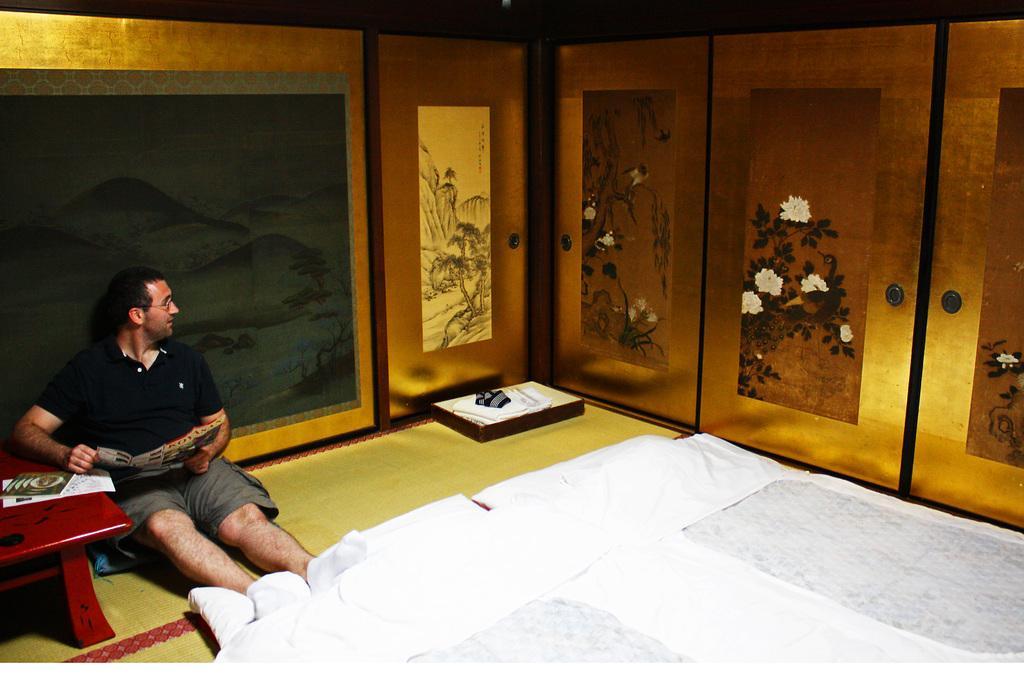Describe this image in one or two sentences. In this picture we can see a man who is sitting on the floor. This is bad. Here we can see a table. On the table there is a book. And this is wall. 